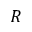Convert formula to latex. <formula><loc_0><loc_0><loc_500><loc_500>R</formula> 